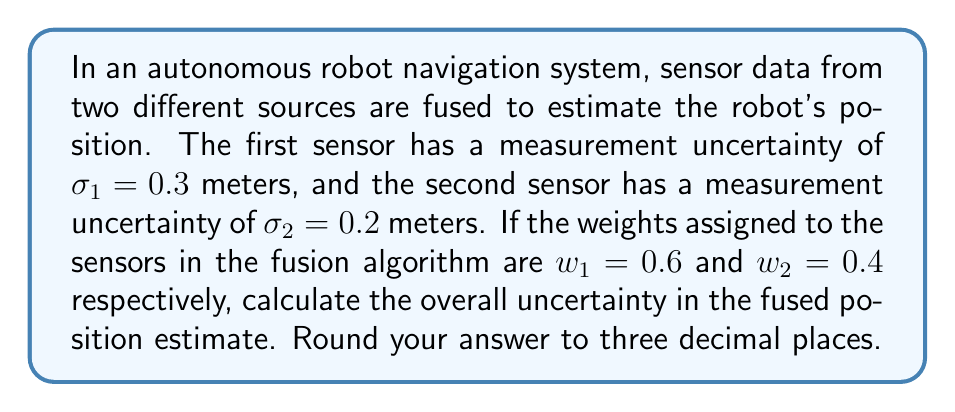Can you solve this math problem? To solve this problem, we'll use the error propagation formula for weighted sensor fusion. The steps are as follows:

1. The general formula for error propagation in weighted sensor fusion is:

   $$\sigma_{fused} = \sqrt{\sum_{i=1}^n w_i^2 \sigma_i^2}$$

   Where:
   - $\sigma_{fused}$ is the uncertainty of the fused estimate
   - $w_i$ are the weights assigned to each sensor
   - $\sigma_i$ are the uncertainties of each sensor measurement

2. In this case, we have two sensors, so we can expand the formula:

   $$\sigma_{fused} = \sqrt{w_1^2 \sigma_1^2 + w_2^2 \sigma_2^2}$$

3. Substituting the given values:
   - $w_1 = 0.6$, $\sigma_1 = 0.3$
   - $w_2 = 0.4$, $\sigma_2 = 0.2$

   $$\sigma_{fused} = \sqrt{(0.6)^2 (0.3)^2 + (0.4)^2 (0.2)^2}$$

4. Simplify the expression under the square root:

   $$\sigma_{fused} = \sqrt{(0.36)(0.09) + (0.16)(0.04)}$$
   $$\sigma_{fused} = \sqrt{0.0324 + 0.0064}$$
   $$\sigma_{fused} = \sqrt{0.0388}$$

5. Calculate the square root and round to three decimal places:

   $$\sigma_{fused} \approx 0.197$$

Therefore, the overall uncertainty in the fused position estimate is approximately 0.197 meters.
Answer: 0.197 meters 